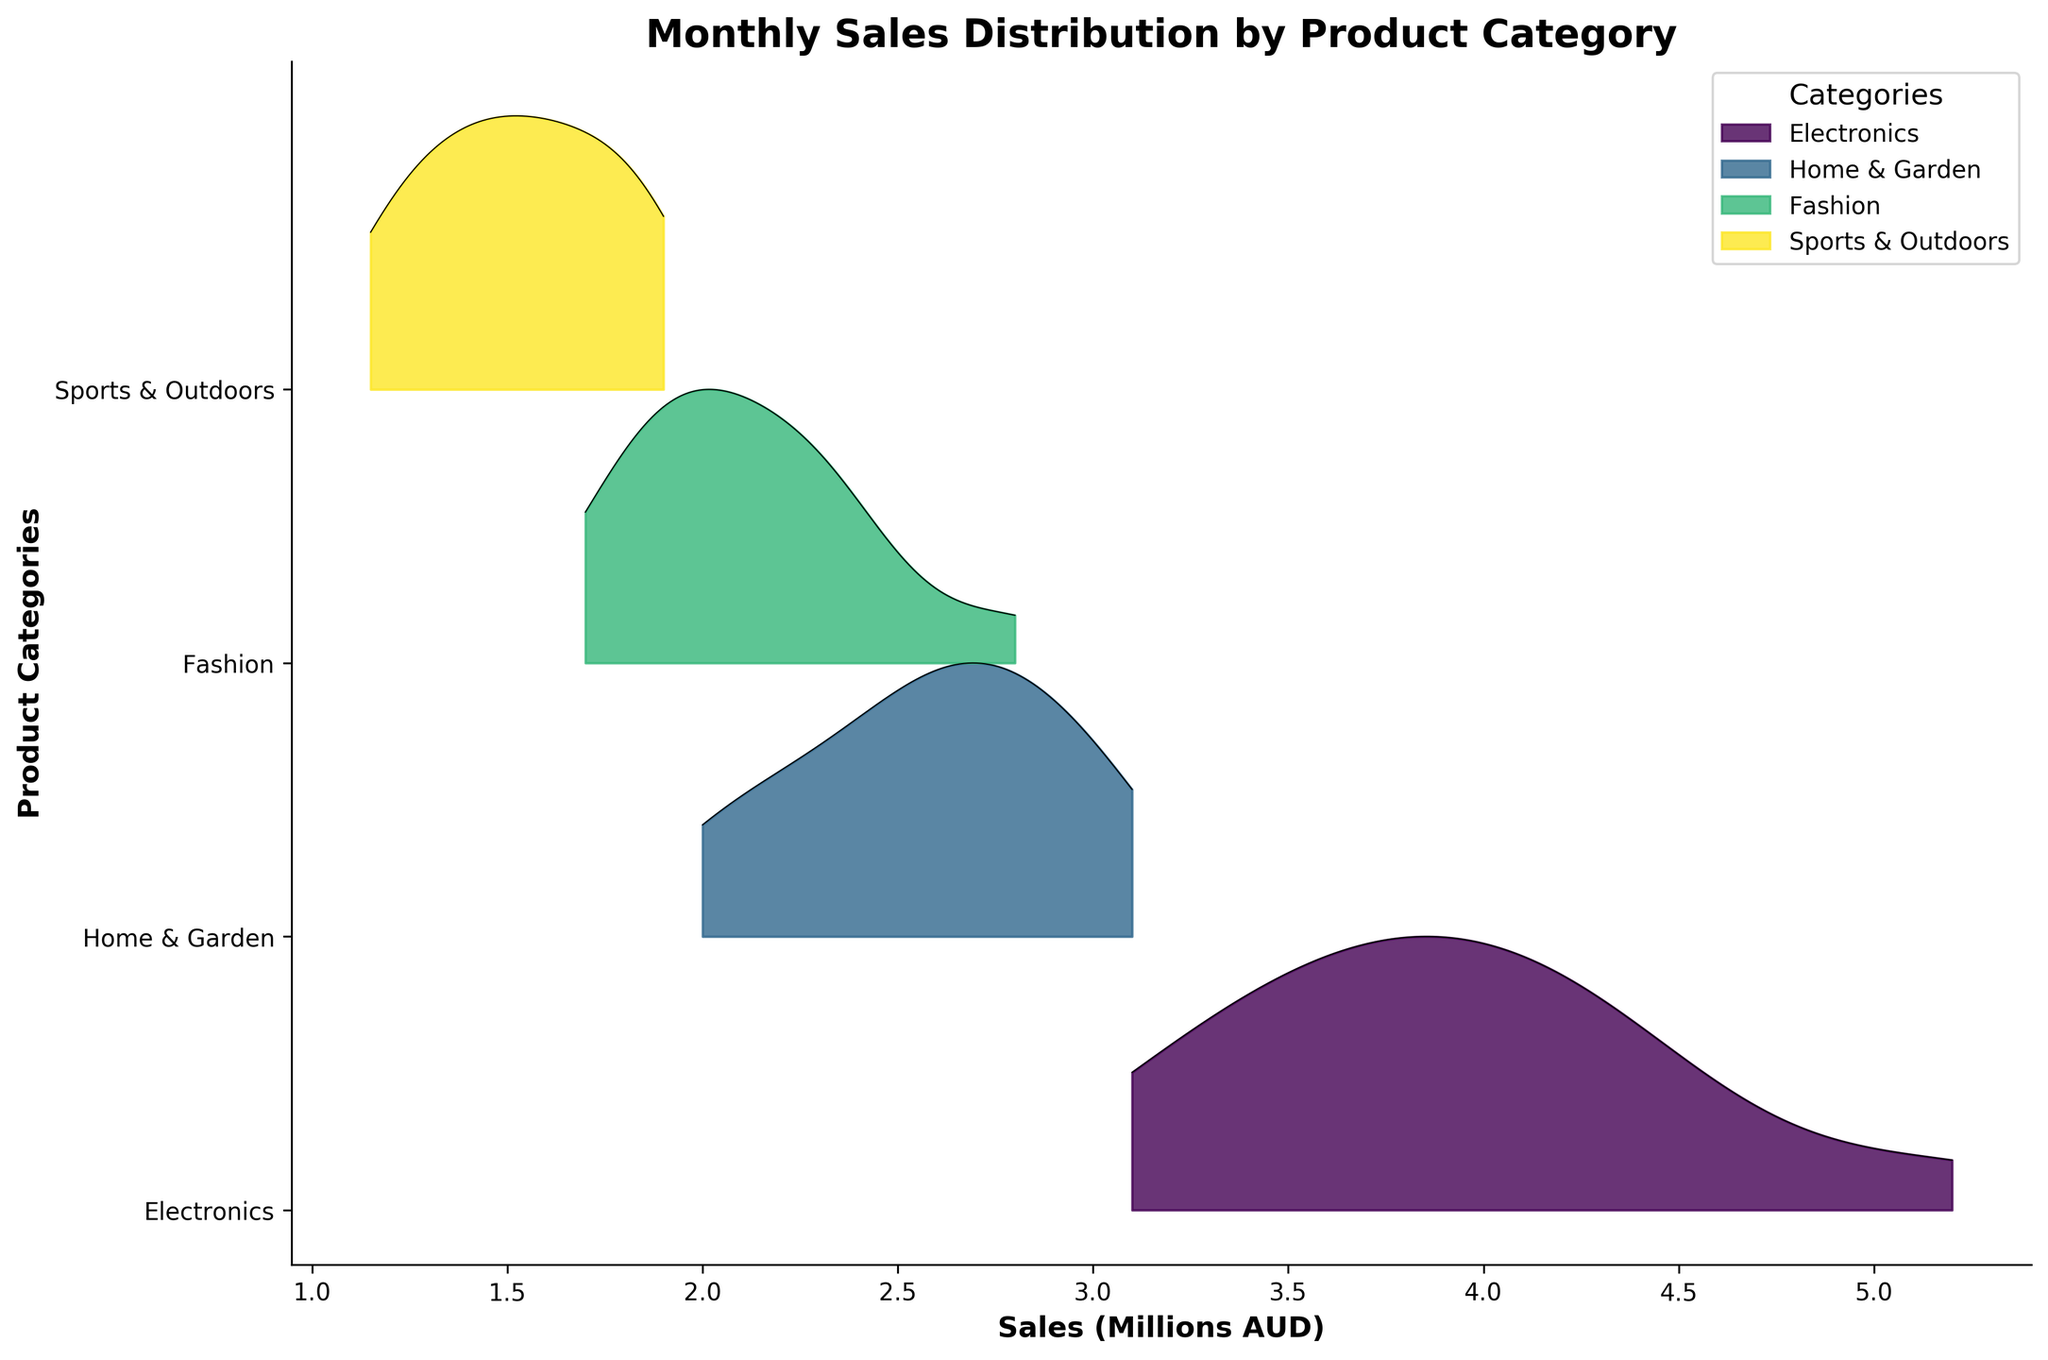What is the title of the figure? The title is located above the figure and is typically the largest and boldest text present. It summarizes what the figure represents.
Answer: Monthly Sales Distribution by Product Category How many different product categories are represented? By looking at the unique labels on the y-axis, each corresponding to a different product category, we can count them.
Answer: 4 Which product category shows the highest peak in sales? A peak in a ridgeline plot is the highest point in the distribution for that category. We compare the heights of the peaks across all categories to identify the highest one.
Answer: Electronics During which months do the Electronics category show higher sales distributions compared to Sports & Outdoors? By comparing the distributions for each month across both categories, check where the Electronics ridgeline is consistently higher than the Sports & Outdoors ridgeline.
Answer: Most months, especially from July to December Which product category appears to have the most consistent (least spread out) sales distribution? Consistency in a ridgeline plot is indicated by a tighter, less spread out distribution. Look for the category with the narrowest bands.
Answer: Sports & Outdoors Is there any month where the Fashion category outperformed Home & Garden in sales? Examine each month’s ridgeline distribution for Fashion and Home & Garden and see if there is any overlap where Fashion's peak surpasses that of Home & Garden.
Answer: No, Home & Garden consistently has higher sales What is the general trend of Home & Garden sales from January to December? Observe the ridgeline peaks from January to December for Home & Garden to spot if they generally incline, decline, or remain level over time.
Answer: Generally inclining How do the sales distributions of Home & Garden in June compare to those in December? Compare the heights and spread of the ridgeline plots for June and December in the Home & Garden category to identify any noticeable differences.
Answer: December is higher and more spread out Which months have the highest sales for the Fashion category? Identify the months where the ridgeline peaks are the highest for the Fashion category.
Answer: November and December 